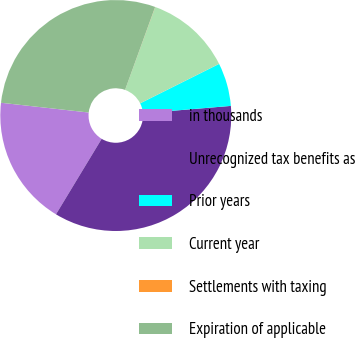<chart> <loc_0><loc_0><loc_500><loc_500><pie_chart><fcel>in thousands<fcel>Unrecognized tax benefits as<fcel>Prior years<fcel>Current year<fcel>Settlements with taxing<fcel>Expiration of applicable<nl><fcel>18.1%<fcel>34.99%<fcel>6.05%<fcel>12.07%<fcel>0.02%<fcel>28.77%<nl></chart> 